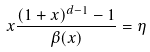Convert formula to latex. <formula><loc_0><loc_0><loc_500><loc_500>x \frac { ( 1 + x ) ^ { d - 1 } - 1 } { \beta ( x ) } = \eta</formula> 